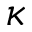Convert formula to latex. <formula><loc_0><loc_0><loc_500><loc_500>\kappa</formula> 